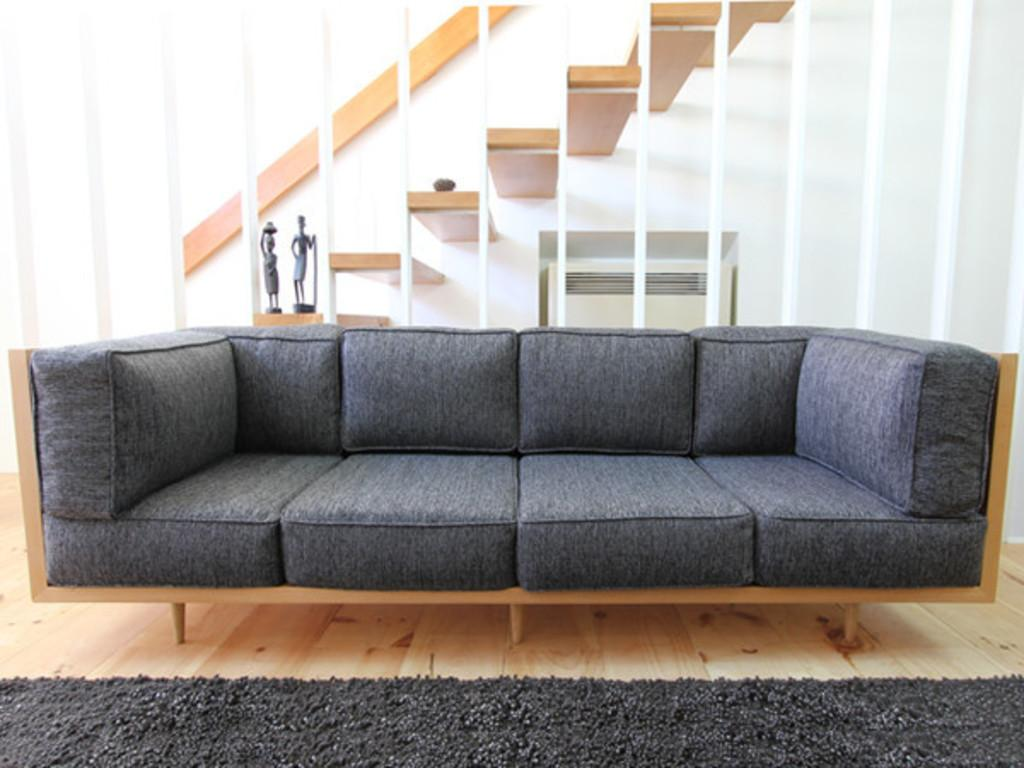What type of furniture is present in the image? There is a sofa in the image. What is on the floor near the sofa? There is a floor mat in the image. Where are the sculptures located in the image? The sculptures are on the stairs in the image. What color is the shelf visible inside the building in the image? There is a white color shelf inside the building in the image. What type of pan is hanging on the wall in the image? There is no pan present in the image. What kind of flag is visible in the image? There is no flag visible in the image. 